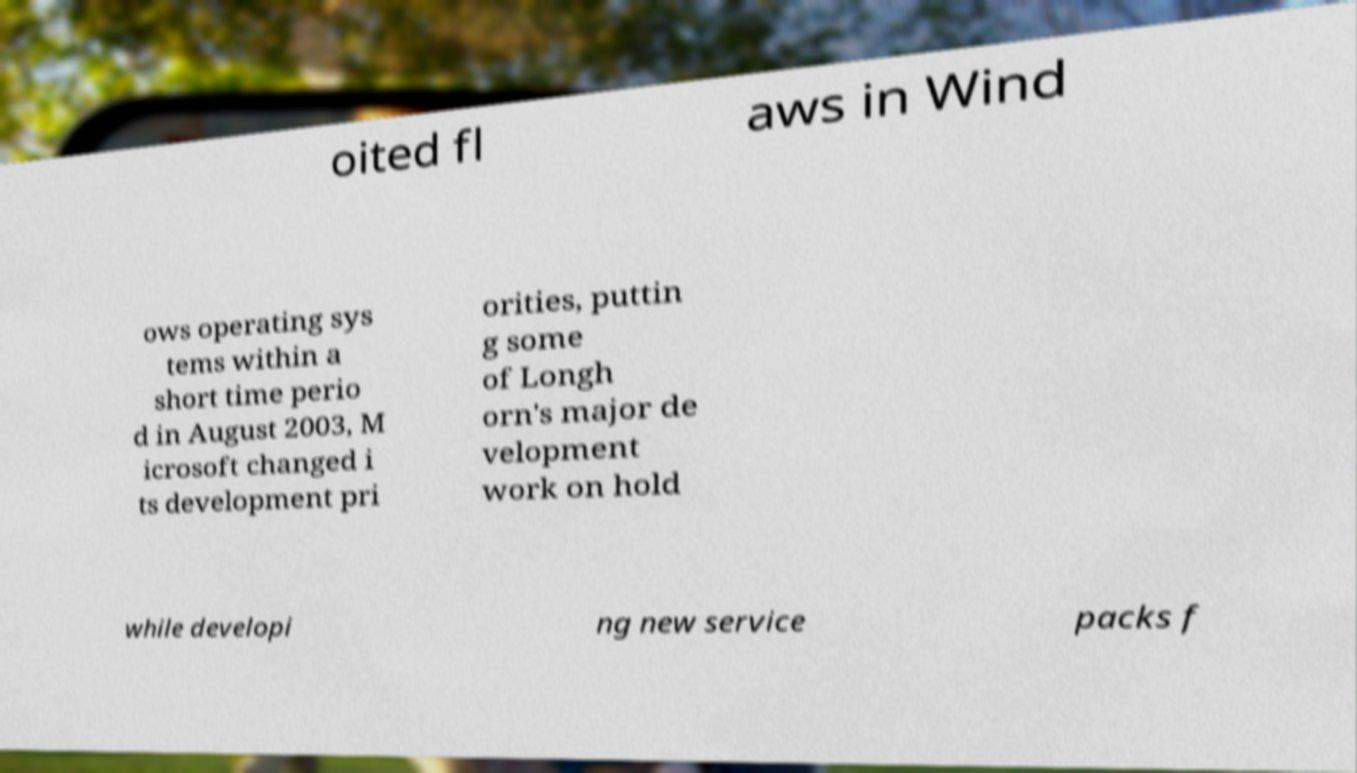What messages or text are displayed in this image? I need them in a readable, typed format. oited fl aws in Wind ows operating sys tems within a short time perio d in August 2003, M icrosoft changed i ts development pri orities, puttin g some of Longh orn's major de velopment work on hold while developi ng new service packs f 